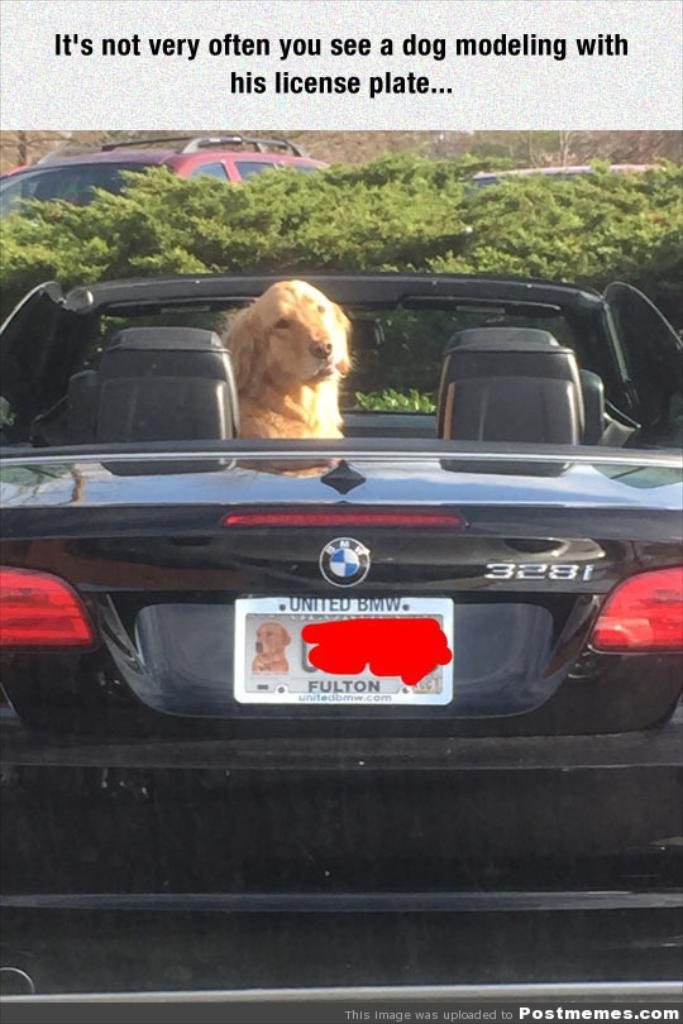What animal is inside the car in the image? There is a dog in the car. What can be seen in the background of the image? There are cars and shrubs visible in the background. Is there any text present in the image? Yes, there is some text visible at the top of the image. What is the name of the brass wren featured in the image? There is no brass wren present in the image; it features a dog in a car with background elements of cars and shrubs, and some text at the top. 